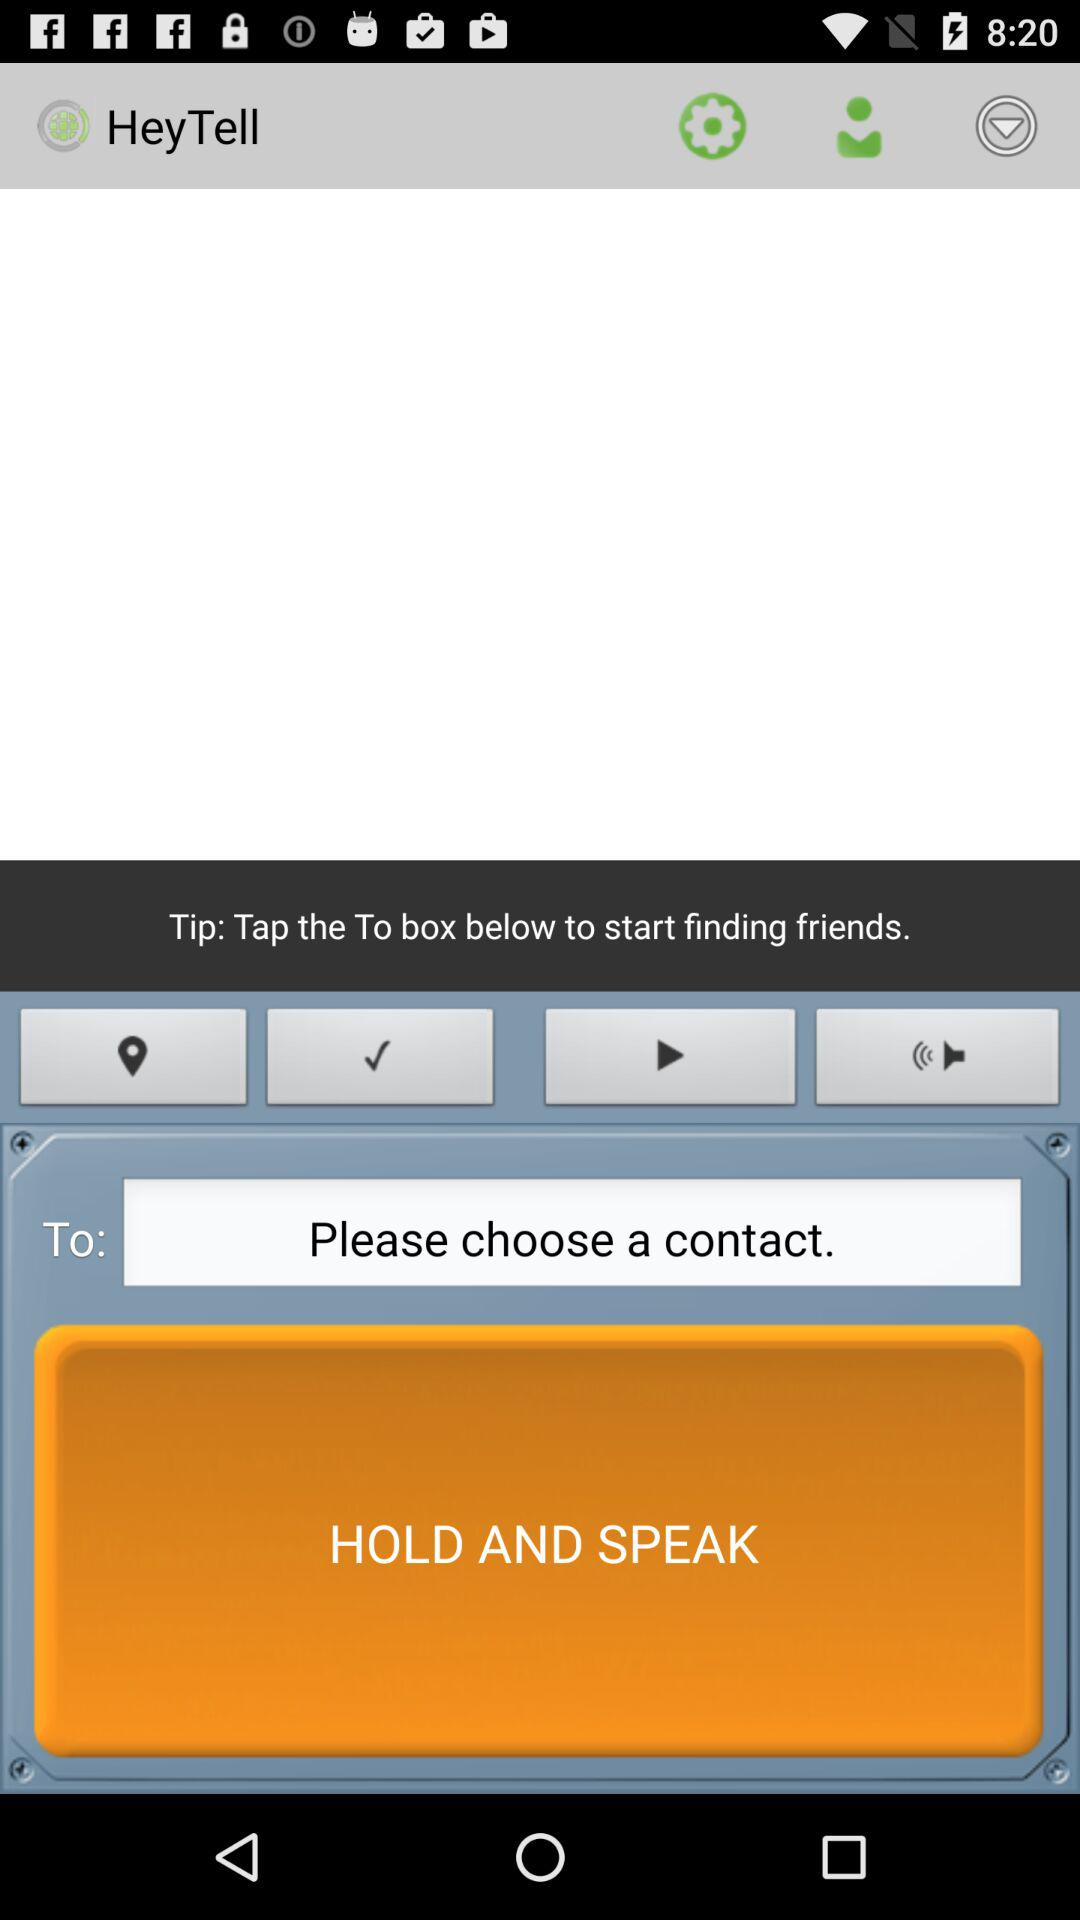What is the name of the application? The application name is "HeyTell". 